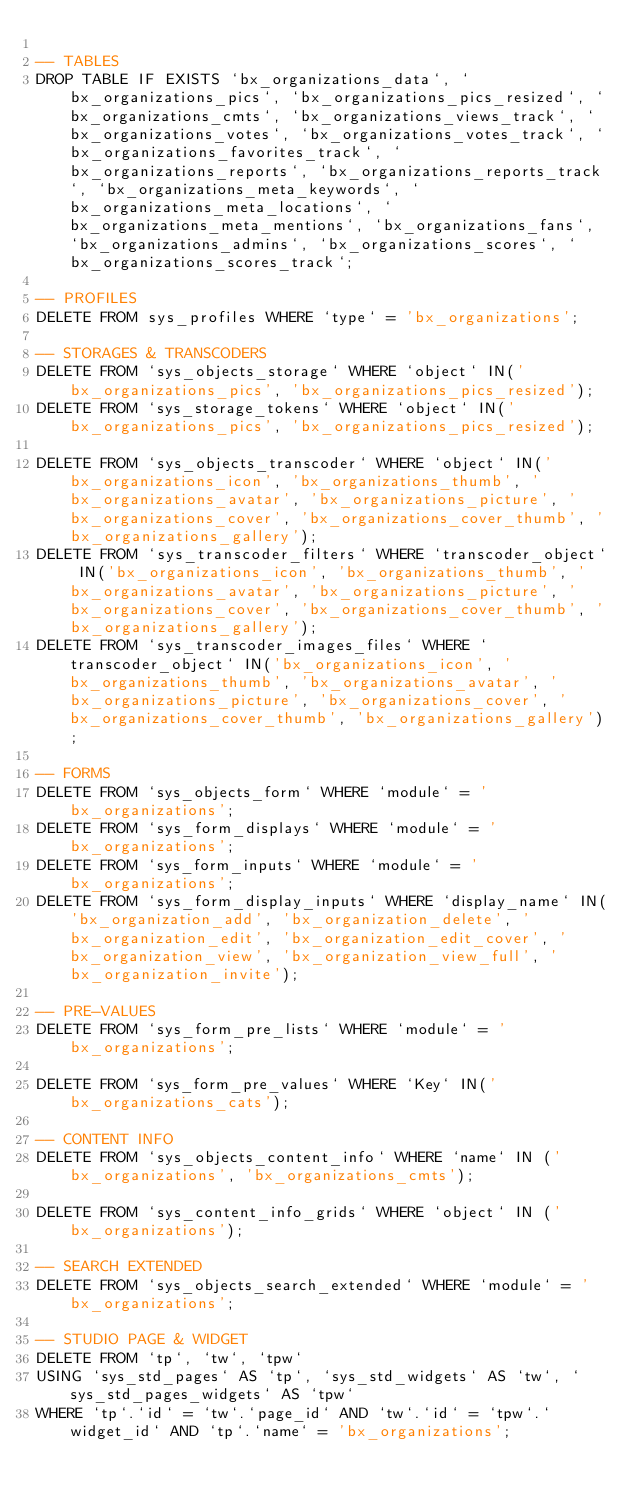Convert code to text. <code><loc_0><loc_0><loc_500><loc_500><_SQL_>
-- TABLES
DROP TABLE IF EXISTS `bx_organizations_data`, `bx_organizations_pics`, `bx_organizations_pics_resized`, `bx_organizations_cmts`, `bx_organizations_views_track`, `bx_organizations_votes`, `bx_organizations_votes_track`, `bx_organizations_favorites_track`, `bx_organizations_reports`, `bx_organizations_reports_track`, `bx_organizations_meta_keywords`, `bx_organizations_meta_locations`, `bx_organizations_meta_mentions`, `bx_organizations_fans`, `bx_organizations_admins`, `bx_organizations_scores`, `bx_organizations_scores_track`;

-- PROFILES
DELETE FROM sys_profiles WHERE `type` = 'bx_organizations';

-- STORAGES & TRANSCODERS
DELETE FROM `sys_objects_storage` WHERE `object` IN('bx_organizations_pics', 'bx_organizations_pics_resized');
DELETE FROM `sys_storage_tokens` WHERE `object` IN('bx_organizations_pics', 'bx_organizations_pics_resized');

DELETE FROM `sys_objects_transcoder` WHERE `object` IN('bx_organizations_icon', 'bx_organizations_thumb', 'bx_organizations_avatar', 'bx_organizations_picture', 'bx_organizations_cover', 'bx_organizations_cover_thumb', 'bx_organizations_gallery');
DELETE FROM `sys_transcoder_filters` WHERE `transcoder_object` IN('bx_organizations_icon', 'bx_organizations_thumb', 'bx_organizations_avatar', 'bx_organizations_picture', 'bx_organizations_cover', 'bx_organizations_cover_thumb', 'bx_organizations_gallery');
DELETE FROM `sys_transcoder_images_files` WHERE `transcoder_object` IN('bx_organizations_icon', 'bx_organizations_thumb', 'bx_organizations_avatar', 'bx_organizations_picture', 'bx_organizations_cover', 'bx_organizations_cover_thumb', 'bx_organizations_gallery');

-- FORMS
DELETE FROM `sys_objects_form` WHERE `module` = 'bx_organizations';
DELETE FROM `sys_form_displays` WHERE `module` = 'bx_organizations';
DELETE FROM `sys_form_inputs` WHERE `module` = 'bx_organizations';
DELETE FROM `sys_form_display_inputs` WHERE `display_name` IN('bx_organization_add', 'bx_organization_delete', 'bx_organization_edit', 'bx_organization_edit_cover', 'bx_organization_view', 'bx_organization_view_full', 'bx_organization_invite');

-- PRE-VALUES
DELETE FROM `sys_form_pre_lists` WHERE `module` = 'bx_organizations';

DELETE FROM `sys_form_pre_values` WHERE `Key` IN('bx_organizations_cats');

-- CONTENT INFO
DELETE FROM `sys_objects_content_info` WHERE `name` IN ('bx_organizations', 'bx_organizations_cmts');

DELETE FROM `sys_content_info_grids` WHERE `object` IN ('bx_organizations');

-- SEARCH EXTENDED
DELETE FROM `sys_objects_search_extended` WHERE `module` = 'bx_organizations';

-- STUDIO PAGE & WIDGET
DELETE FROM `tp`, `tw`, `tpw`
USING `sys_std_pages` AS `tp`, `sys_std_widgets` AS `tw`, `sys_std_pages_widgets` AS `tpw`
WHERE `tp`.`id` = `tw`.`page_id` AND `tw`.`id` = `tpw`.`widget_id` AND `tp`.`name` = 'bx_organizations';
</code> 